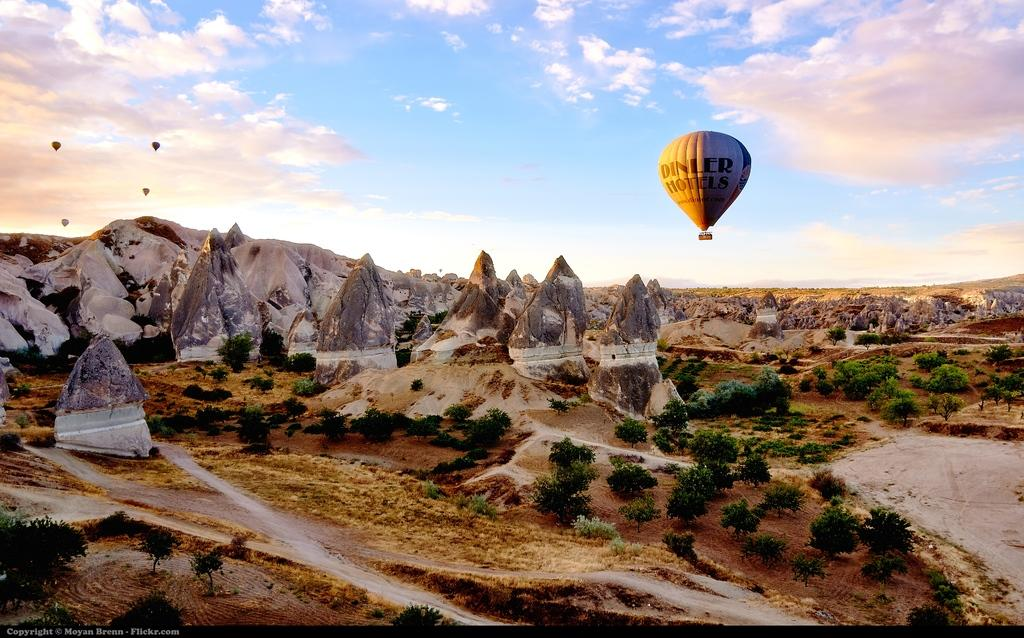How many hot air balloons are visible in the sky in the image? There are five hot air balloons in the sky in the image. What other objects can be seen in the image besides the hot air balloons? There are many big stones and trees visible in the image. What type of fish can be seen swimming in the river in the image? There is no river or fish present in the image. What type of work is the laborer doing in the image? There is no laborer or work being done in the image. 